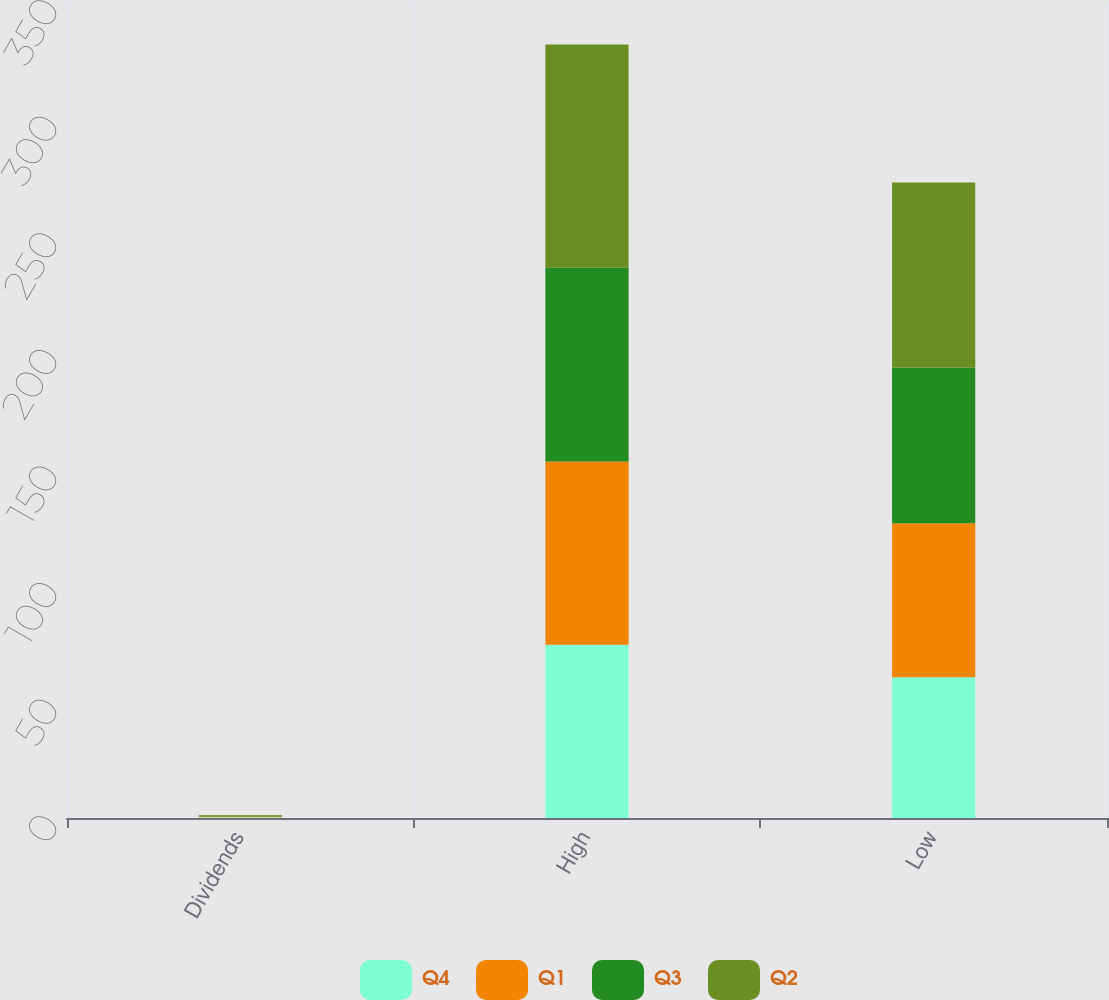<chart> <loc_0><loc_0><loc_500><loc_500><stacked_bar_chart><ecel><fcel>Dividends<fcel>High<fcel>Low<nl><fcel>Q4<fcel>0.27<fcel>74.35<fcel>60.41<nl><fcel>Q1<fcel>0.33<fcel>78.61<fcel>65.99<nl><fcel>Q3<fcel>0.33<fcel>83.08<fcel>66.84<nl><fcel>Q2<fcel>0.38<fcel>95.78<fcel>79.32<nl></chart> 